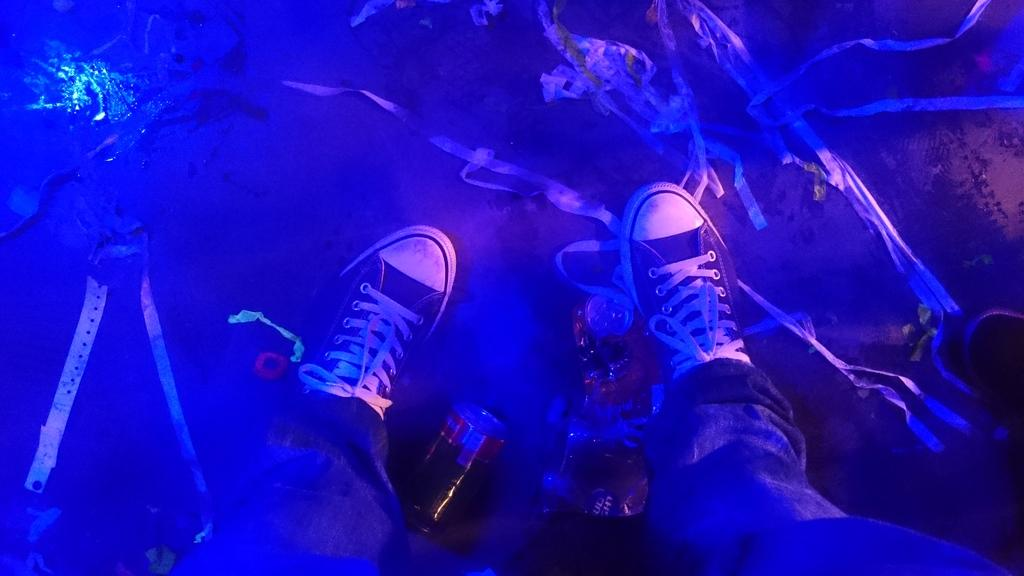What body parts are visible in the image? The image contains human legs. What type of footwear is the person wearing? The person is wearing shoes. What object is beside the legs in the image? There is a coke bottle beside the legs. What color is the background of the image? The background of the image is blue in color. What type of window can be seen in the image? There is no window present in the image; it only contains human legs, shoes, a coke bottle, and a blue background. What type of collar is visible on the person's shirt in the image? There is no shirt or collar visible in the image, as only the person's legs are shown. 